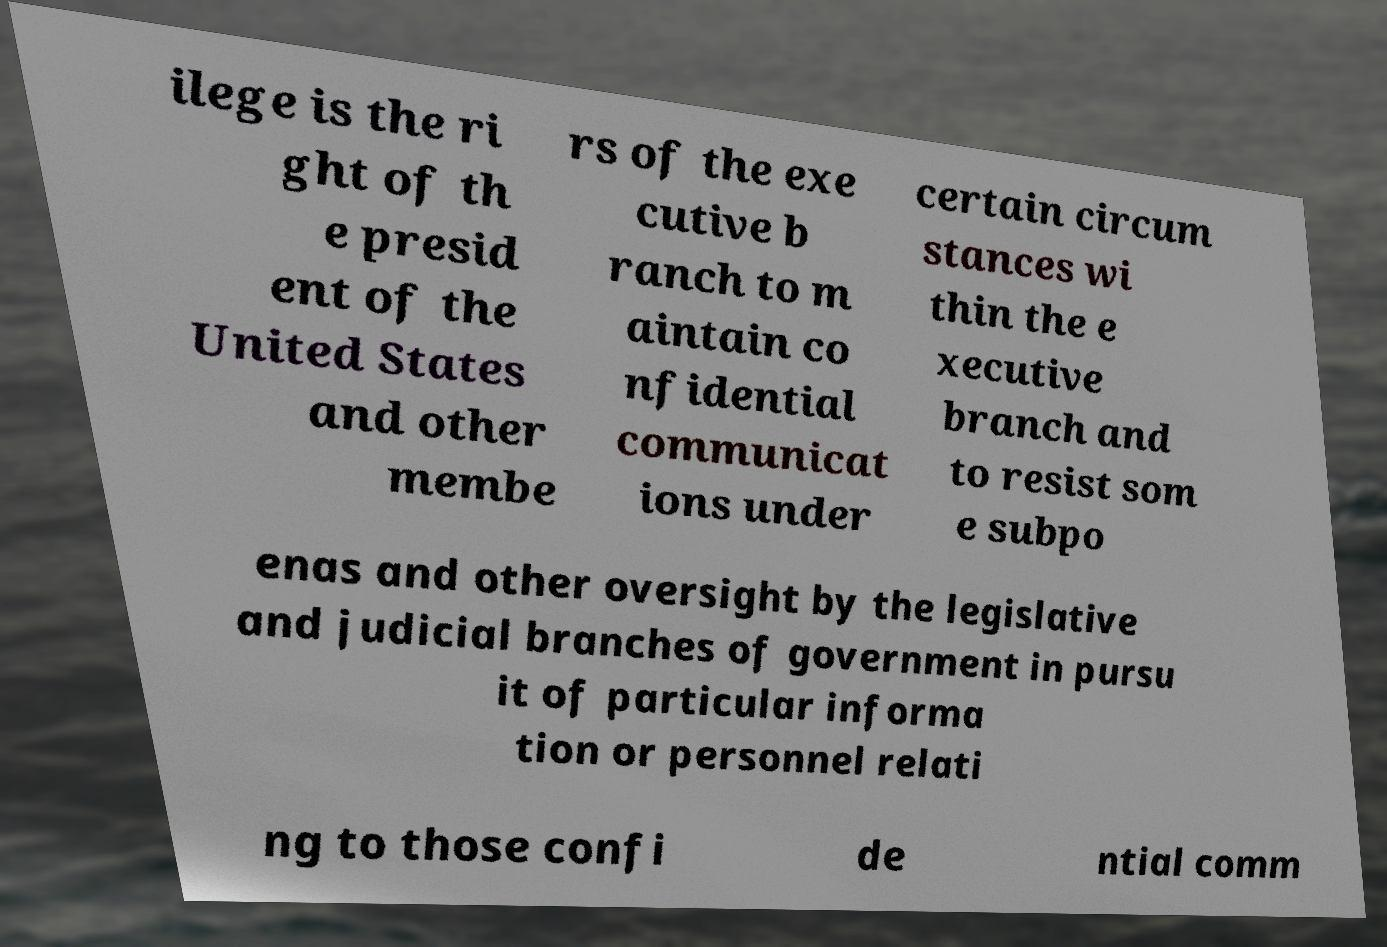Can you read and provide the text displayed in the image?This photo seems to have some interesting text. Can you extract and type it out for me? ilege is the ri ght of th e presid ent of the United States and other membe rs of the exe cutive b ranch to m aintain co nfidential communicat ions under certain circum stances wi thin the e xecutive branch and to resist som e subpo enas and other oversight by the legislative and judicial branches of government in pursu it of particular informa tion or personnel relati ng to those confi de ntial comm 